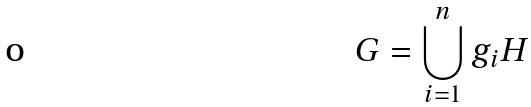Convert formula to latex. <formula><loc_0><loc_0><loc_500><loc_500>G = \bigcup _ { i = 1 } ^ { n } g _ { i } H</formula> 